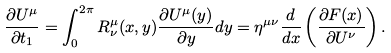Convert formula to latex. <formula><loc_0><loc_0><loc_500><loc_500>\frac { \partial U ^ { \mu } } { \partial t _ { 1 } } = \int _ { 0 } ^ { 2 \pi } R ^ { \mu } _ { \nu } ( x , y ) \frac { \partial U ^ { \mu } ( y ) } { \partial y } d y = \eta ^ { \mu \nu } \frac { d } { d x } \left ( \frac { \partial F ( x ) } { \partial U ^ { \nu } } \right ) .</formula> 